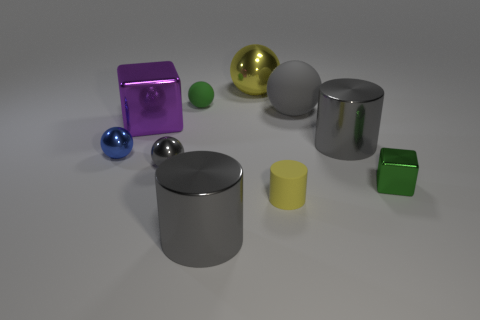How many big rubber things are the same color as the small rubber cylinder?
Your answer should be compact. 0. What number of things are either metal objects on the left side of the large metallic cube or purple shiny cubes?
Ensure brevity in your answer.  2. How big is the cube that is right of the tiny green rubber ball?
Make the answer very short. Small. Is the number of tiny gray matte things less than the number of small yellow cylinders?
Offer a very short reply. Yes. Do the big ball behind the big gray rubber ball and the large cylinder that is on the right side of the yellow ball have the same material?
Your answer should be compact. Yes. There is a large shiny object that is to the left of the large cylinder to the left of the large thing that is behind the large gray matte ball; what is its shape?
Keep it short and to the point. Cube. What number of other tiny brown blocks are made of the same material as the small cube?
Your answer should be very brief. 0. There is a big gray cylinder that is in front of the tiny green cube; what number of large cylinders are behind it?
Give a very brief answer. 1. Is the color of the rubber ball right of the yellow ball the same as the metallic cylinder that is in front of the tiny blue metal ball?
Offer a very short reply. Yes. What shape is the small thing that is both right of the large metal ball and behind the small yellow cylinder?
Ensure brevity in your answer.  Cube. 